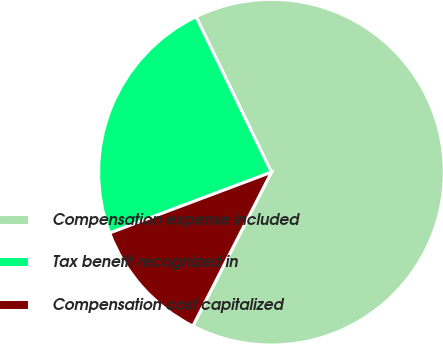<chart> <loc_0><loc_0><loc_500><loc_500><pie_chart><fcel>Compensation expense included<fcel>Tax benefit recognized in<fcel>Compensation cost capitalized<nl><fcel>64.71%<fcel>23.53%<fcel>11.76%<nl></chart> 